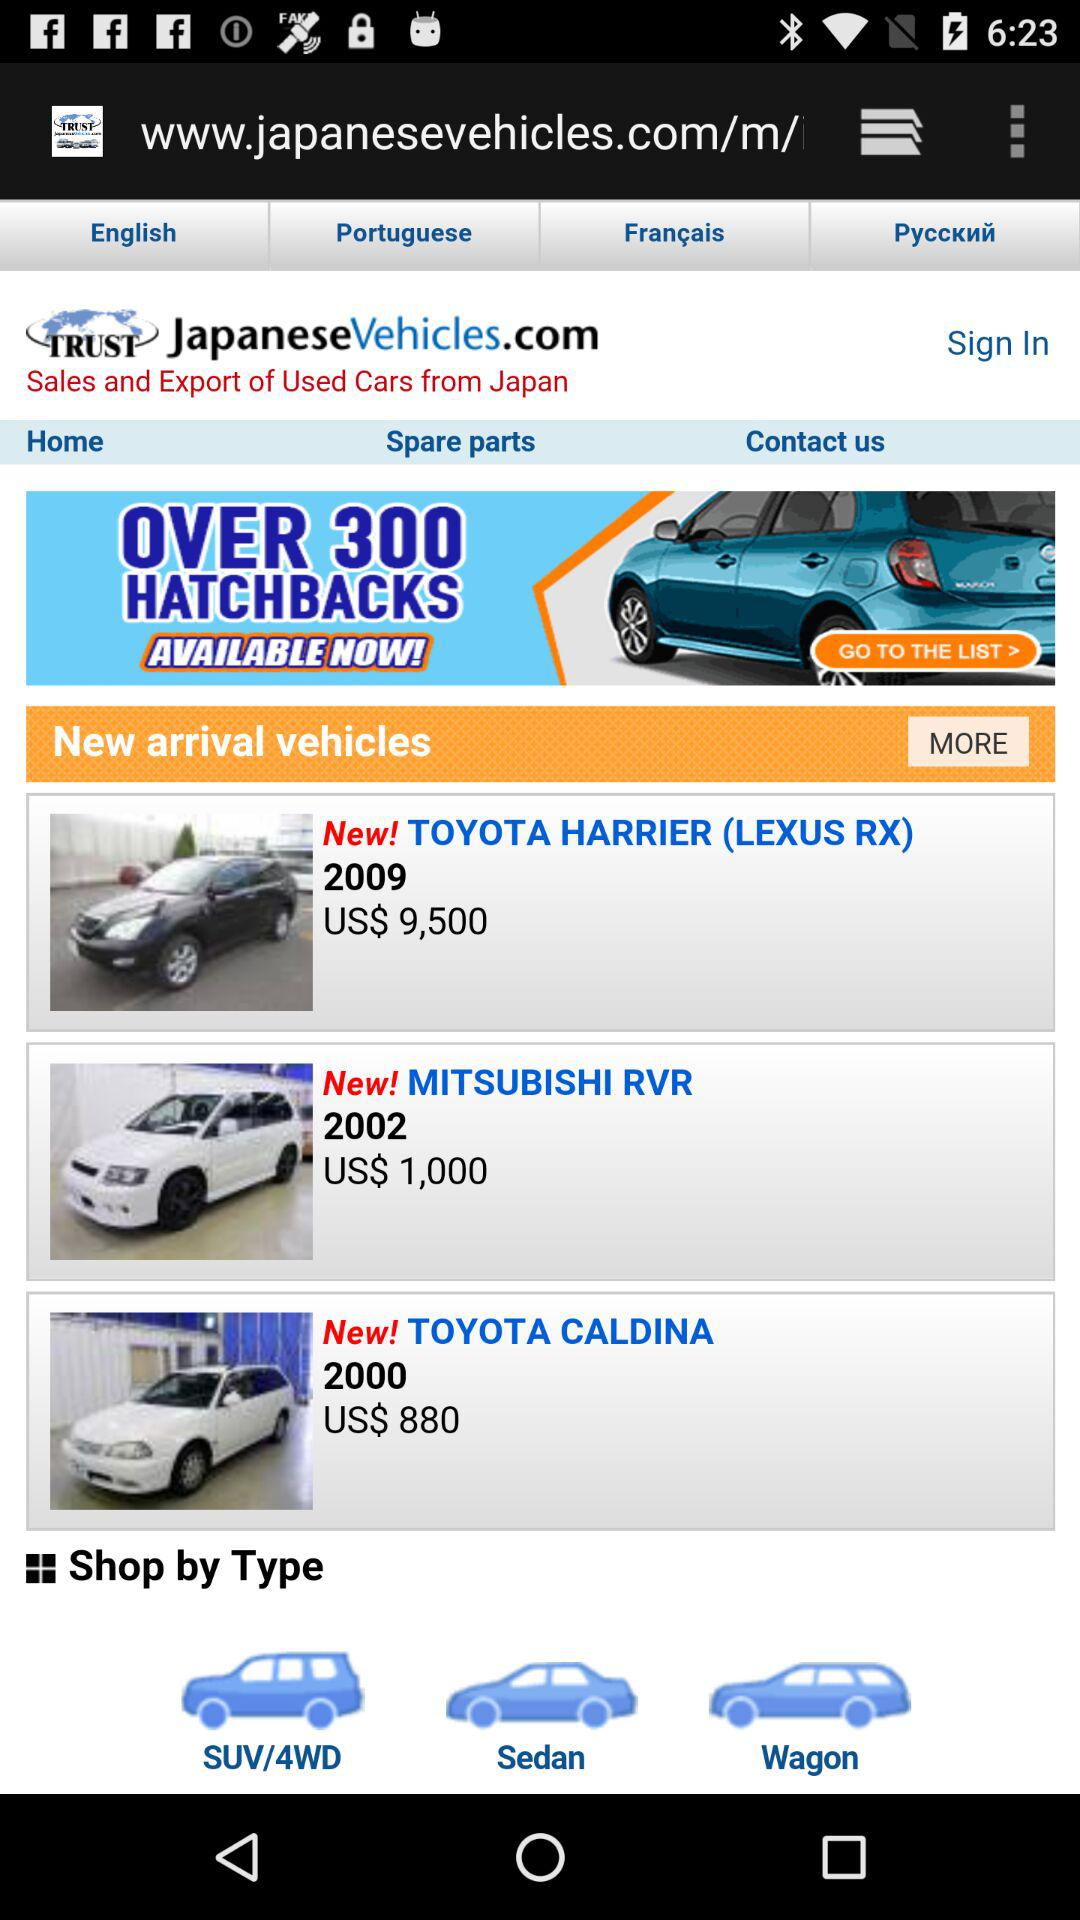What is the cost of the "TOYOTA HARRIER (LEXUS RX)"? The cost is US$ 9,500. 